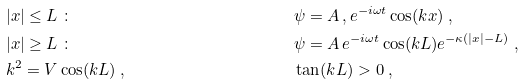Convert formula to latex. <formula><loc_0><loc_0><loc_500><loc_500>& | x | \leq L \ \colon \ & & \psi = A \, , e ^ { - i \omega t } \cos ( k x ) \ , \\ & | x | \geq L \ \colon \ & & \psi = A \, e ^ { - i \omega t } \cos ( k L ) e ^ { - \kappa ( | x | - L ) } \ , \\ & k ^ { 2 } = V \cos ( k L ) \ , & & \tan ( k L ) > 0 \ ,</formula> 